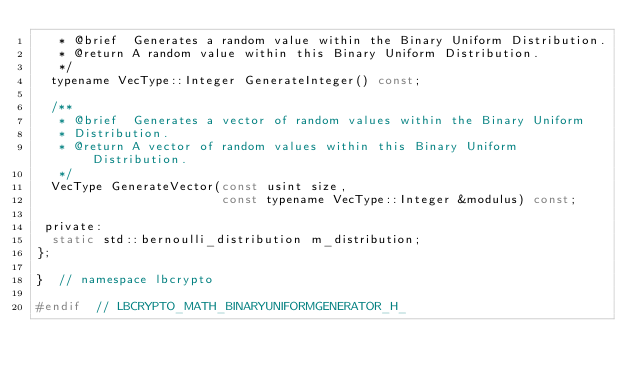Convert code to text. <code><loc_0><loc_0><loc_500><loc_500><_C_>   * @brief  Generates a random value within the Binary Uniform Distribution.
   * @return A random value within this Binary Uniform Distribution.
   */
  typename VecType::Integer GenerateInteger() const;

  /**
   * @brief  Generates a vector of random values within the Binary Uniform
   * Distribution.
   * @return A vector of random values within this Binary Uniform Distribution.
   */
  VecType GenerateVector(const usint size,
                         const typename VecType::Integer &modulus) const;

 private:
  static std::bernoulli_distribution m_distribution;
};

}  // namespace lbcrypto

#endif  // LBCRYPTO_MATH_BINARYUNIFORMGENERATOR_H_
</code> 